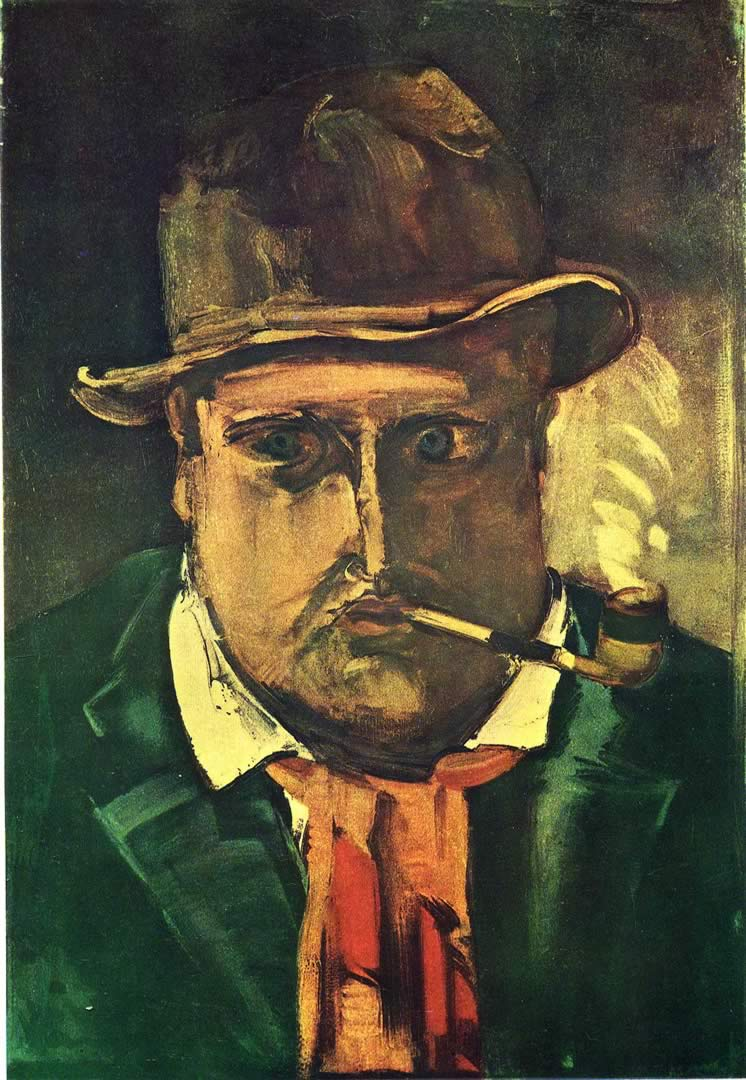Can you describe the main features of this image for me? The image is an oil painting that captures a man in an expressionist style. The man, adorned with a hat, is seen smoking a pipe. The artist has employed a palette dominated by dark greens and browns, punctuated with occasional red and yellow accents. The man's face and attire are depicted with a certain degree of distortion and exaggeration, a characteristic trait of the expressionist art genre. The painting likely hails from the early 20th century, a period when expressionism was at its peak. The overall composition and style of the painting strongly suggest its categorization within the expressionist art genre. 